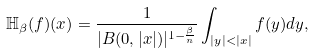<formula> <loc_0><loc_0><loc_500><loc_500>\mathbb { H } _ { \beta } ( f ) ( x ) = \frac { 1 } { | B ( 0 , | x | ) | ^ { 1 - \frac { \beta } { n } } } \int _ { | y | < | x | } f ( y ) d y ,</formula> 